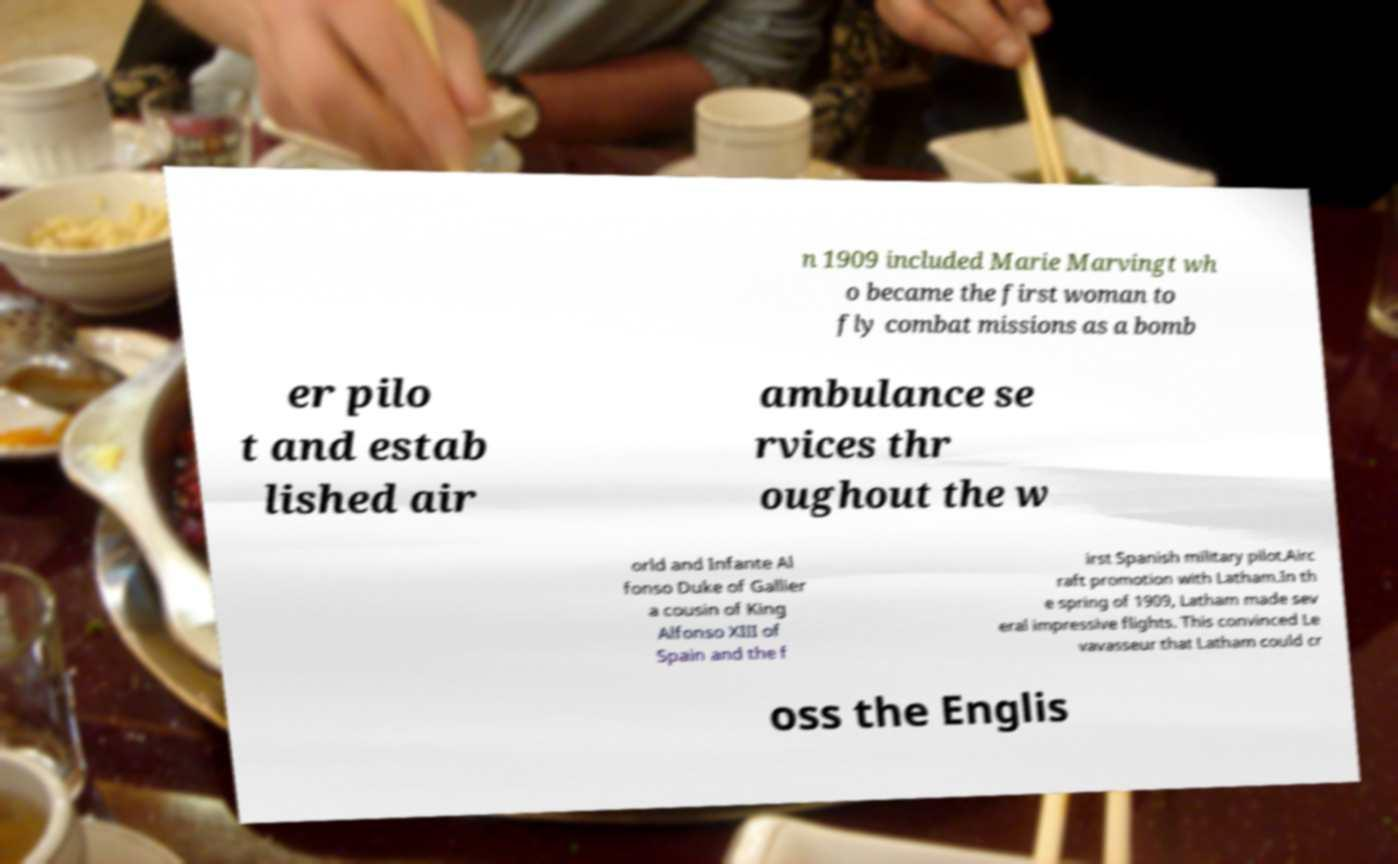For documentation purposes, I need the text within this image transcribed. Could you provide that? n 1909 included Marie Marvingt wh o became the first woman to fly combat missions as a bomb er pilo t and estab lished air ambulance se rvices thr oughout the w orld and Infante Al fonso Duke of Gallier a cousin of King Alfonso XIII of Spain and the f irst Spanish military pilot.Airc raft promotion with Latham.In th e spring of 1909, Latham made sev eral impressive flights. This convinced Le vavasseur that Latham could cr oss the Englis 